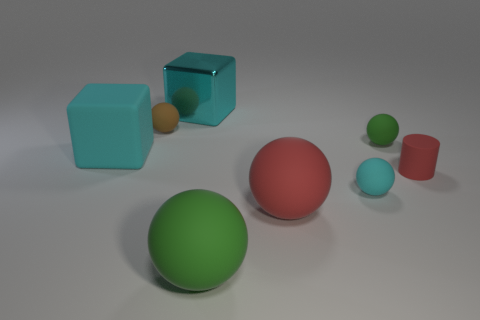Are there any red matte cylinders of the same size as the brown matte thing?
Ensure brevity in your answer.  Yes. Are there any big blocks of the same color as the tiny cylinder?
Your response must be concise. No. Is there anything else that is the same size as the brown object?
Your answer should be compact. Yes. What number of rubber blocks are the same color as the metal thing?
Offer a terse response. 1. There is a large matte cube; is it the same color as the matte sphere that is on the right side of the tiny cyan thing?
Make the answer very short. No. What number of objects are either large brown cylinders or small rubber spheres that are behind the small red matte cylinder?
Ensure brevity in your answer.  2. How big is the green sphere in front of the cyan matte thing behind the tiny cyan rubber object?
Your response must be concise. Large. Are there the same number of tiny matte objects right of the cyan matte ball and brown matte balls behind the brown thing?
Give a very brief answer. No. Are there any big red things that are behind the green rubber thing that is right of the small cyan matte object?
Offer a terse response. No. There is a small green object that is the same material as the cyan ball; what is its shape?
Offer a terse response. Sphere. 